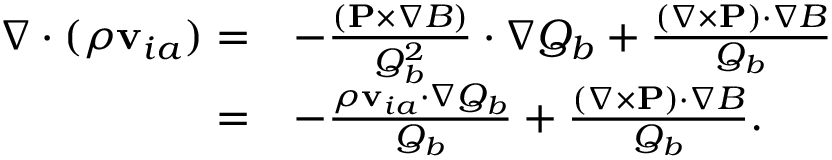<formula> <loc_0><loc_0><loc_500><loc_500>\begin{array} { r l } { \nabla \cdot ( \rho { v } _ { i a } ) = } & { - \frac { ( { P } \times \nabla B ) } { Q _ { b } ^ { 2 } } \cdot \nabla Q _ { b } + \frac { ( \nabla \times { P } ) \cdot \nabla B } { Q _ { b } } } \\ { = } & { - \frac { \rho { v } _ { i a } \cdot \nabla Q _ { b } } { Q _ { b } } + \frac { ( \nabla \times { P } ) \cdot \nabla B } { Q _ { b } } . } \end{array}</formula> 